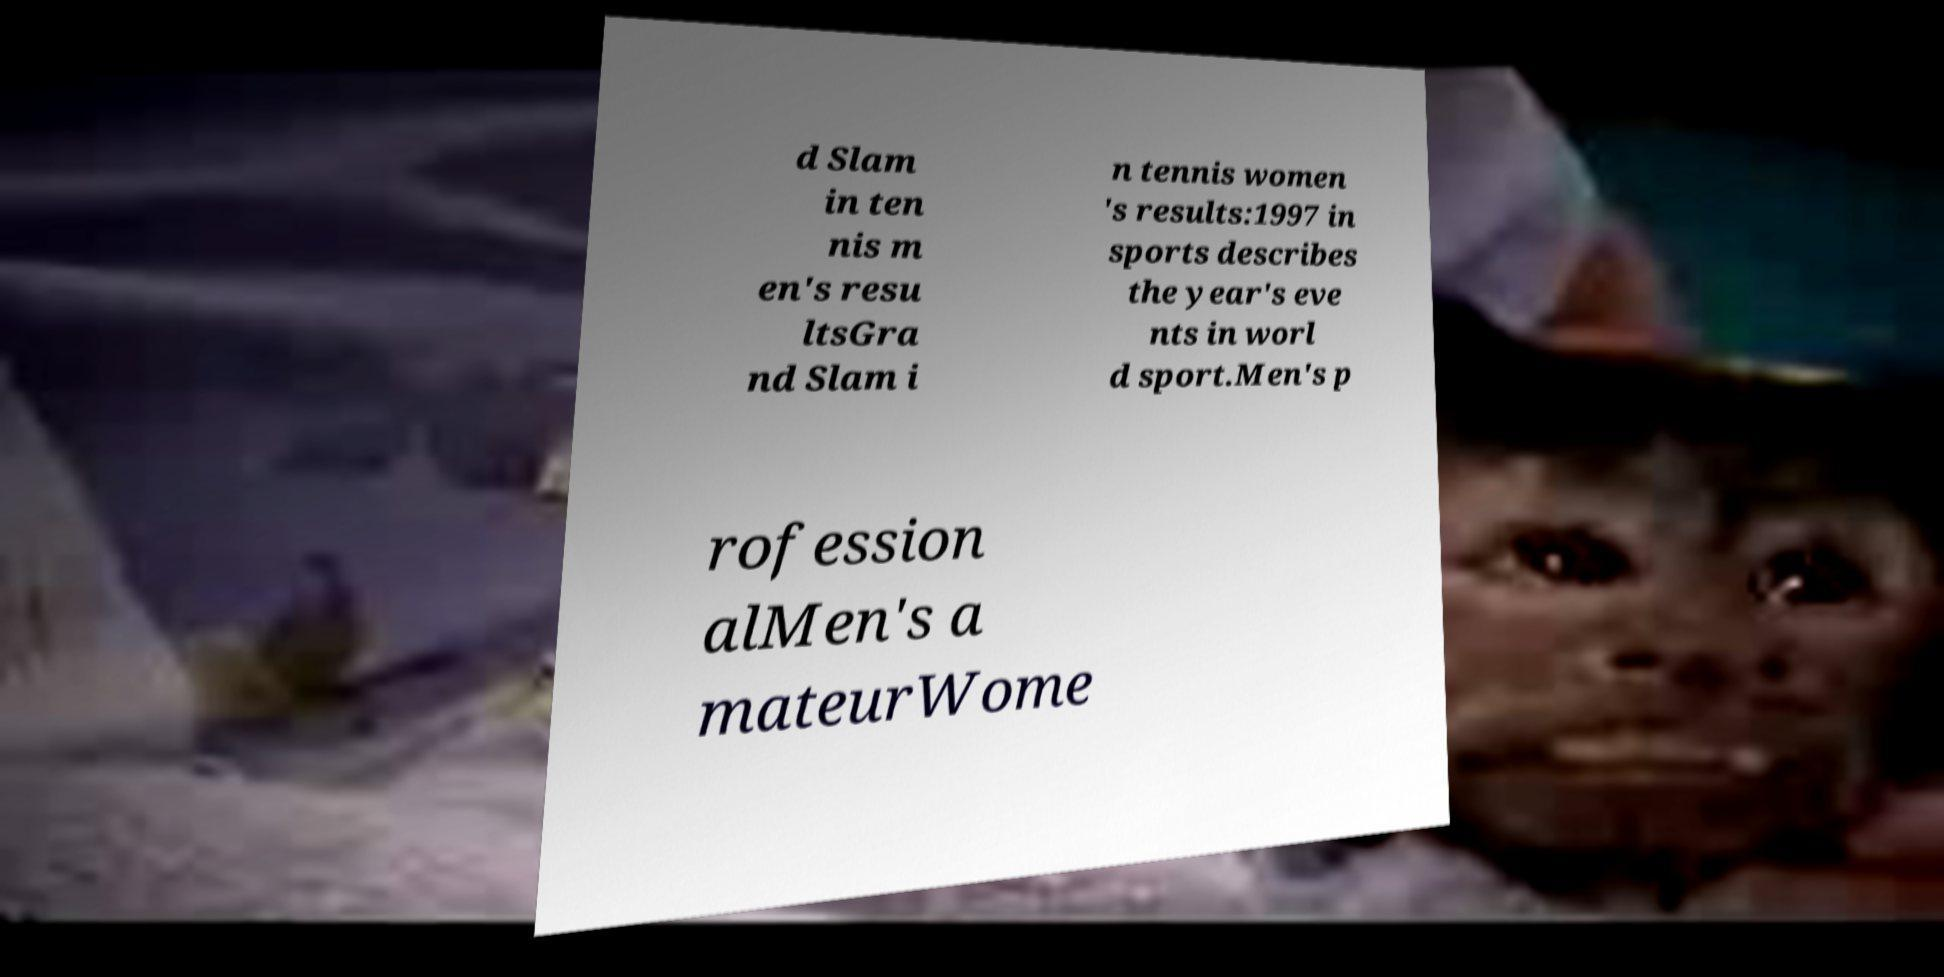Can you accurately transcribe the text from the provided image for me? d Slam in ten nis m en's resu ltsGra nd Slam i n tennis women 's results:1997 in sports describes the year's eve nts in worl d sport.Men's p rofession alMen's a mateurWome 